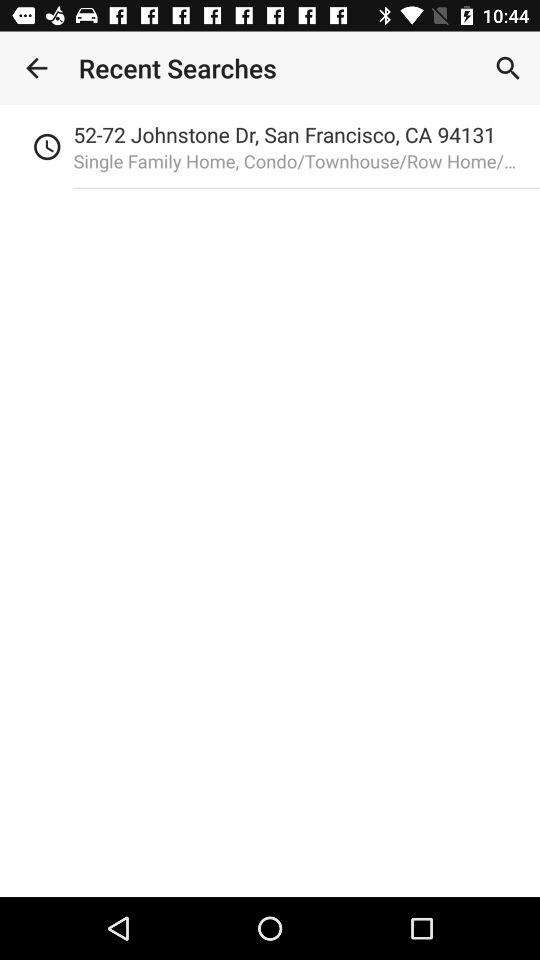What was the last searched location? The last searched location is 52-72 Johnstone Dr, San Francisco, CA 94131. 